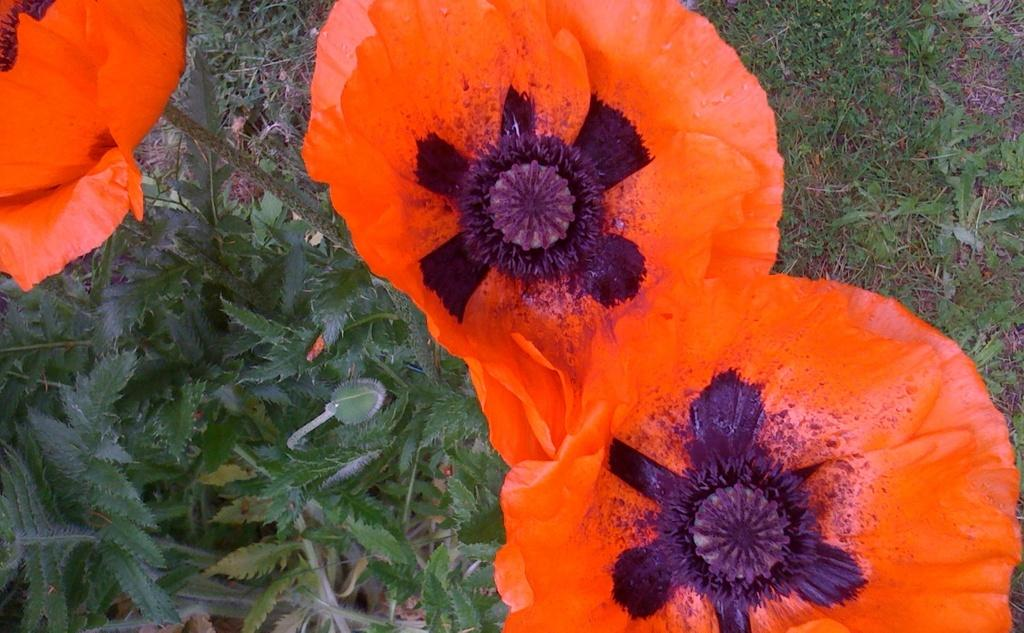What color are the flowers in the image? The flowers in the image are orange-colored. What color are the leaves in the image? The leaves in the image are green-colored. What type of vegetation is on the right side of the image? There is grass on the right side of the image. Where is the wheel located in the image? There is no wheel present in the image. How many icicles are hanging from the flowers in the image? There are no icicles present in the image; it features orange-colored flowers and green-colored leaves. 